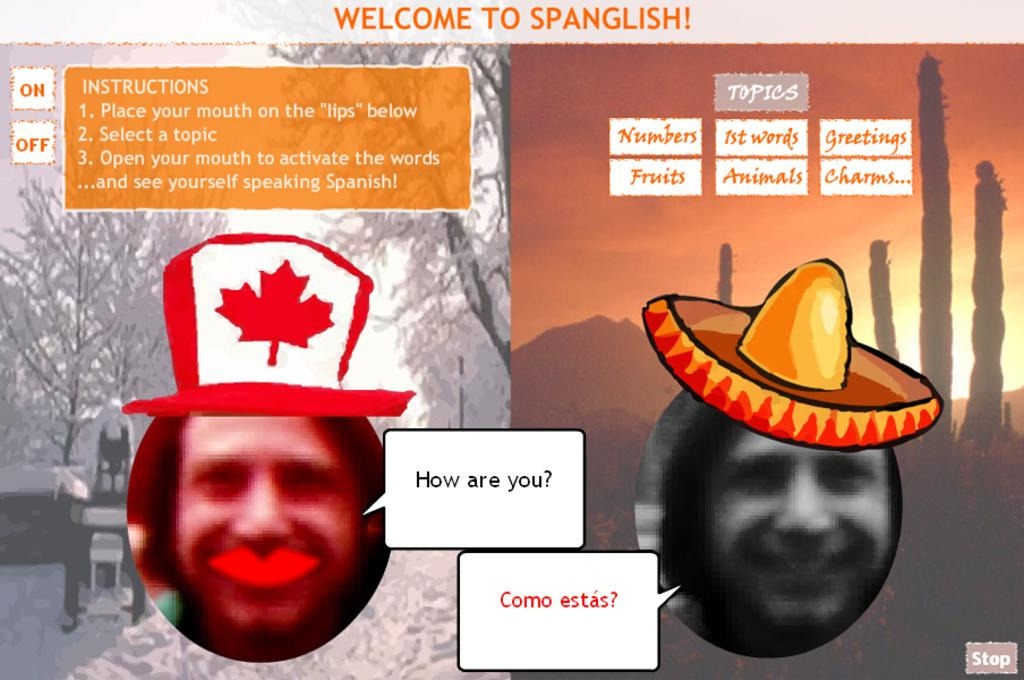What type of photos are present in the image? The image contains collage photos. Can you describe the quality of the faces in the photos? The faces of people in the photos are blurry. What else can be seen in the image besides the collage photos? There is writing present in the image at multiple locations. What type of butter is being used to reduce friction in the image? There is no butter or friction present in the image; it contains collage photos and writing. 